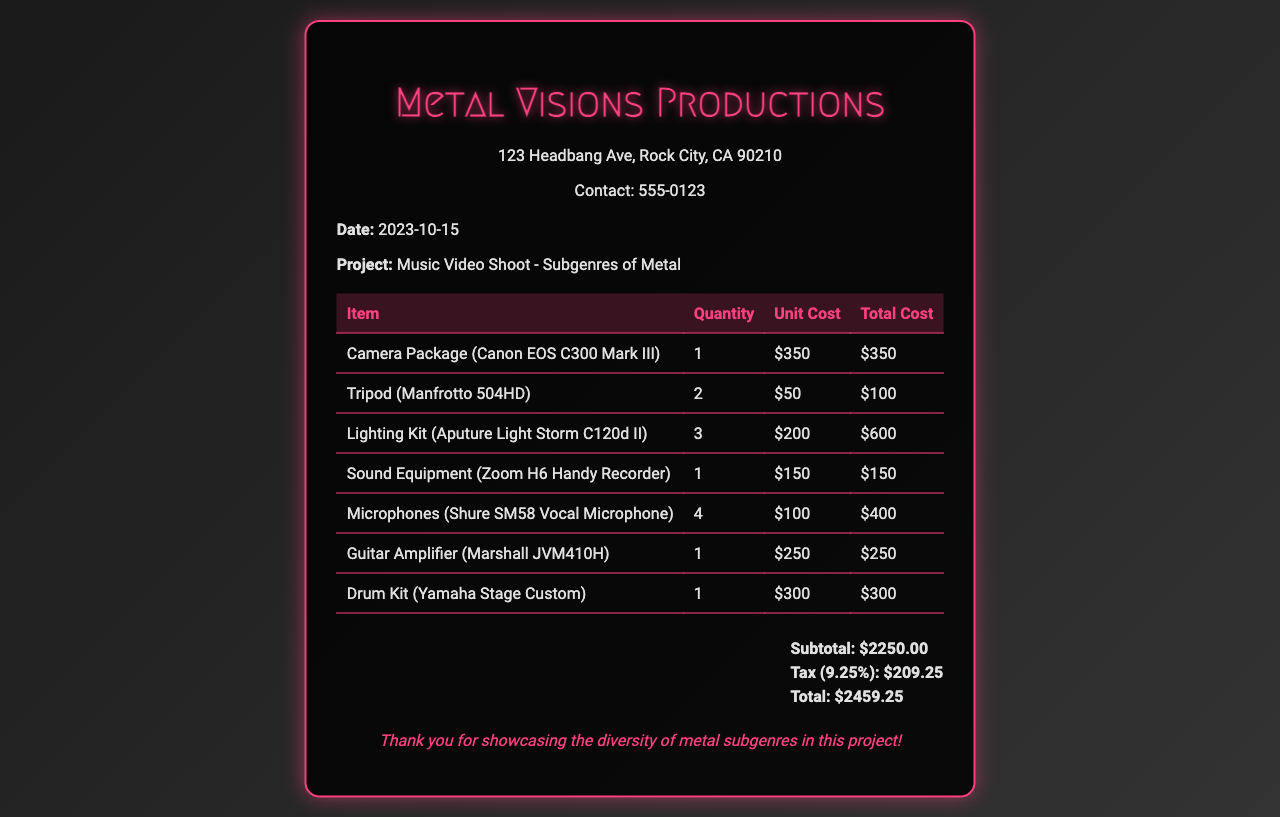What is the date of the receipt? The date of the receipt is specified in the details section of the document.
Answer: 2023-10-15 What is the project title? The project title is mentioned in the details section under the project label.
Answer: Music Video Shoot - Subgenres of Metal What is the total cost of the rental? The total cost is calculated at the end of the receipt after the subtotal and tax.
Answer: $2459.25 How many microphones were rented? The quantity of microphones can be found in the itemized list of equipment.
Answer: 4 What is the unit cost of the camera package? The unit cost for each item is shown in the itemized table.
Answer: $350 What equipment was used for sound recording? The sound recording equipment is listed among the rental items.
Answer: Zoom H6 Handy Recorder What percentage is the tax applied? The tax percentage is shown alongside the total cost calculation.
Answer: 9.25% What is the subtotal before tax? The subtotal is provided in the summary section of the receipt before tax is added.
Answer: $2250.00 What does the receipt thank the customer for? The note at the end expresses gratitude for a specific aspect of the project.
Answer: Showcasing the diversity of metal subgenres 